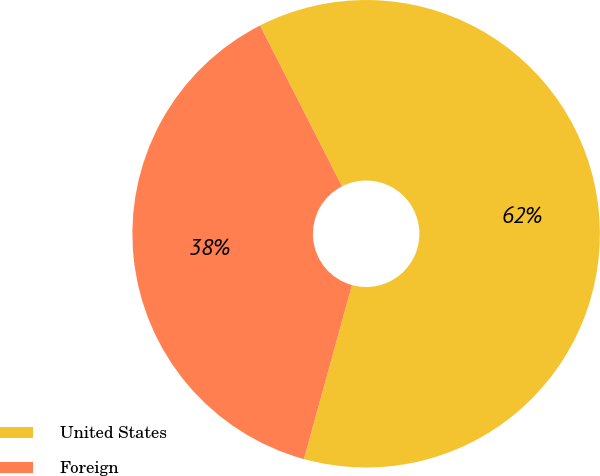Convert chart. <chart><loc_0><loc_0><loc_500><loc_500><pie_chart><fcel>United States<fcel>Foreign<nl><fcel>61.79%<fcel>38.21%<nl></chart> 